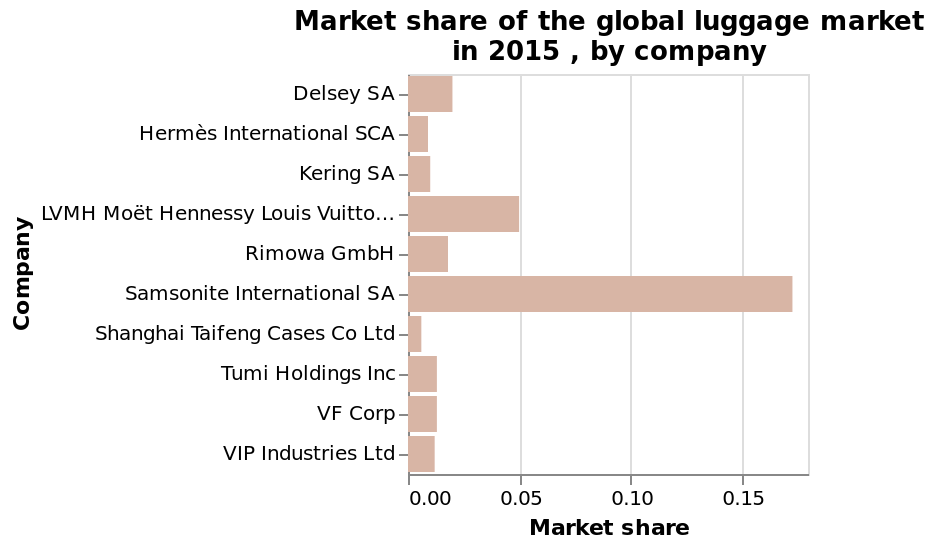<image>
What does the y-axis represent in the bar chart?  The y-axis represents the companies in the global luggage market ranging from Delsey SA to VIP Industries Ltd. please describe the details of the chart Here a bar chart is labeled Market share of the global luggage market in 2015 , by company. Market share is defined along a scale of range 0.00 to 0.15 along the x-axis. On the y-axis, Company is shown as a categorical scale from Delsey SA to VIP Industries Ltd. 